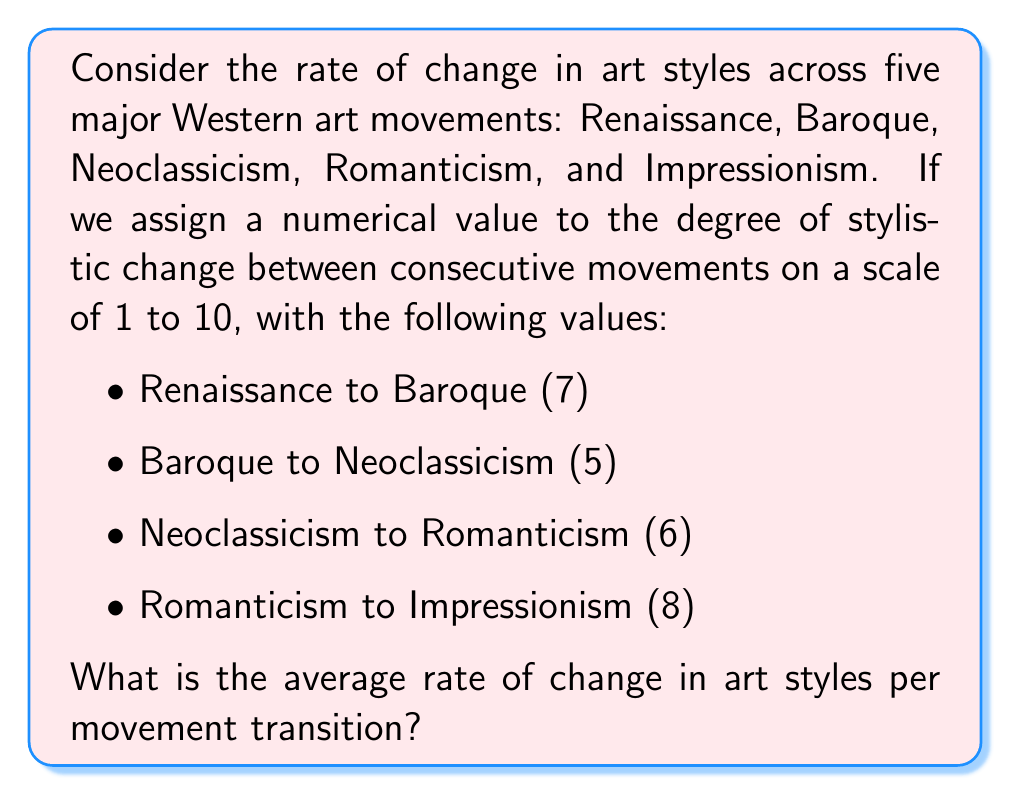Teach me how to tackle this problem. To solve this problem, we'll follow these steps:

1. Identify the given data:
   - Number of transitions between movements: 4
   - Degree of change for each transition:
     * Renaissance to Baroque: 7
     * Baroque to Neoclassicism: 5
     * Neoclassicism to Romanticism: 6
     * Romanticism to Impressionism: 8

2. Calculate the total change across all transitions:
   $$\text{Total change} = 7 + 5 + 6 + 8 = 26$$

3. Calculate the average rate of change by dividing the total change by the number of transitions:
   $$\text{Average rate of change} = \frac{\text{Total change}}{\text{Number of transitions}}$$
   $$\text{Average rate of change} = \frac{26}{4} = 6.5$$

Therefore, the average rate of change in art styles per movement transition is 6.5 on the given scale of 1 to 10.
Answer: 6.5 